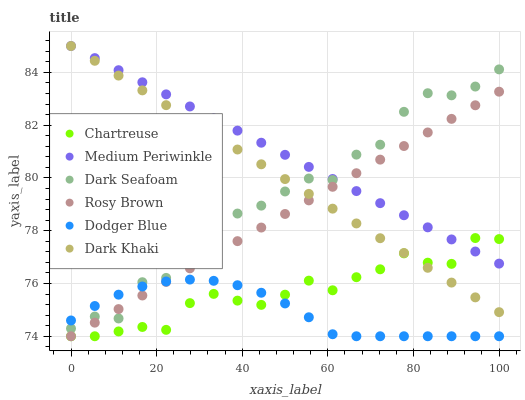Does Dodger Blue have the minimum area under the curve?
Answer yes or no. Yes. Does Medium Periwinkle have the maximum area under the curve?
Answer yes or no. Yes. Does Dark Seafoam have the minimum area under the curve?
Answer yes or no. No. Does Dark Seafoam have the maximum area under the curve?
Answer yes or no. No. Is Medium Periwinkle the smoothest?
Answer yes or no. Yes. Is Dark Seafoam the roughest?
Answer yes or no. Yes. Is Dark Seafoam the smoothest?
Answer yes or no. No. Is Medium Periwinkle the roughest?
Answer yes or no. No. Does Rosy Brown have the lowest value?
Answer yes or no. Yes. Does Dark Seafoam have the lowest value?
Answer yes or no. No. Does Dark Khaki have the highest value?
Answer yes or no. Yes. Does Dark Seafoam have the highest value?
Answer yes or no. No. Is Dodger Blue less than Dark Khaki?
Answer yes or no. Yes. Is Dark Khaki greater than Dodger Blue?
Answer yes or no. Yes. Does Dark Seafoam intersect Dodger Blue?
Answer yes or no. Yes. Is Dark Seafoam less than Dodger Blue?
Answer yes or no. No. Is Dark Seafoam greater than Dodger Blue?
Answer yes or no. No. Does Dodger Blue intersect Dark Khaki?
Answer yes or no. No. 